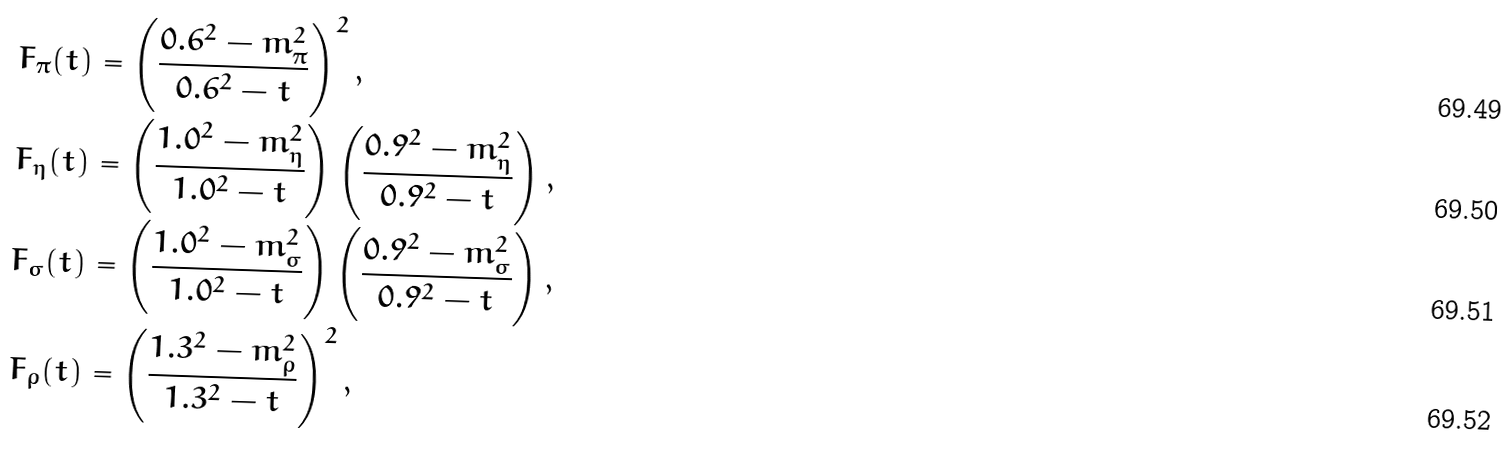<formula> <loc_0><loc_0><loc_500><loc_500>F _ { \pi } ( t ) & = \left ( \frac { 0 . 6 ^ { 2 } - m _ { \pi } ^ { 2 } } { 0 . 6 ^ { 2 } - t } \right ) ^ { 2 } , \\ F _ { \eta } ( t ) & = \left ( \frac { 1 . 0 ^ { 2 } - m _ { \eta } ^ { 2 } } { 1 . 0 ^ { 2 } - t } \right ) \left ( \frac { 0 . 9 ^ { 2 } - m _ { \eta } ^ { 2 } } { 0 . 9 ^ { 2 } - t } \right ) , \\ F _ { \sigma } ( t ) & = \left ( \frac { 1 . 0 ^ { 2 } - m _ { \sigma } ^ { 2 } } { 1 . 0 ^ { 2 } - t } \right ) \left ( \frac { 0 . 9 ^ { 2 } - m _ { \sigma } ^ { 2 } } { 0 . 9 ^ { 2 } - t } \right ) , \\ F _ { \rho } ( t ) & = \left ( \frac { 1 . 3 ^ { 2 } - m _ { \rho } ^ { 2 } } { 1 . 3 ^ { 2 } - t } \right ) ^ { 2 } ,</formula> 